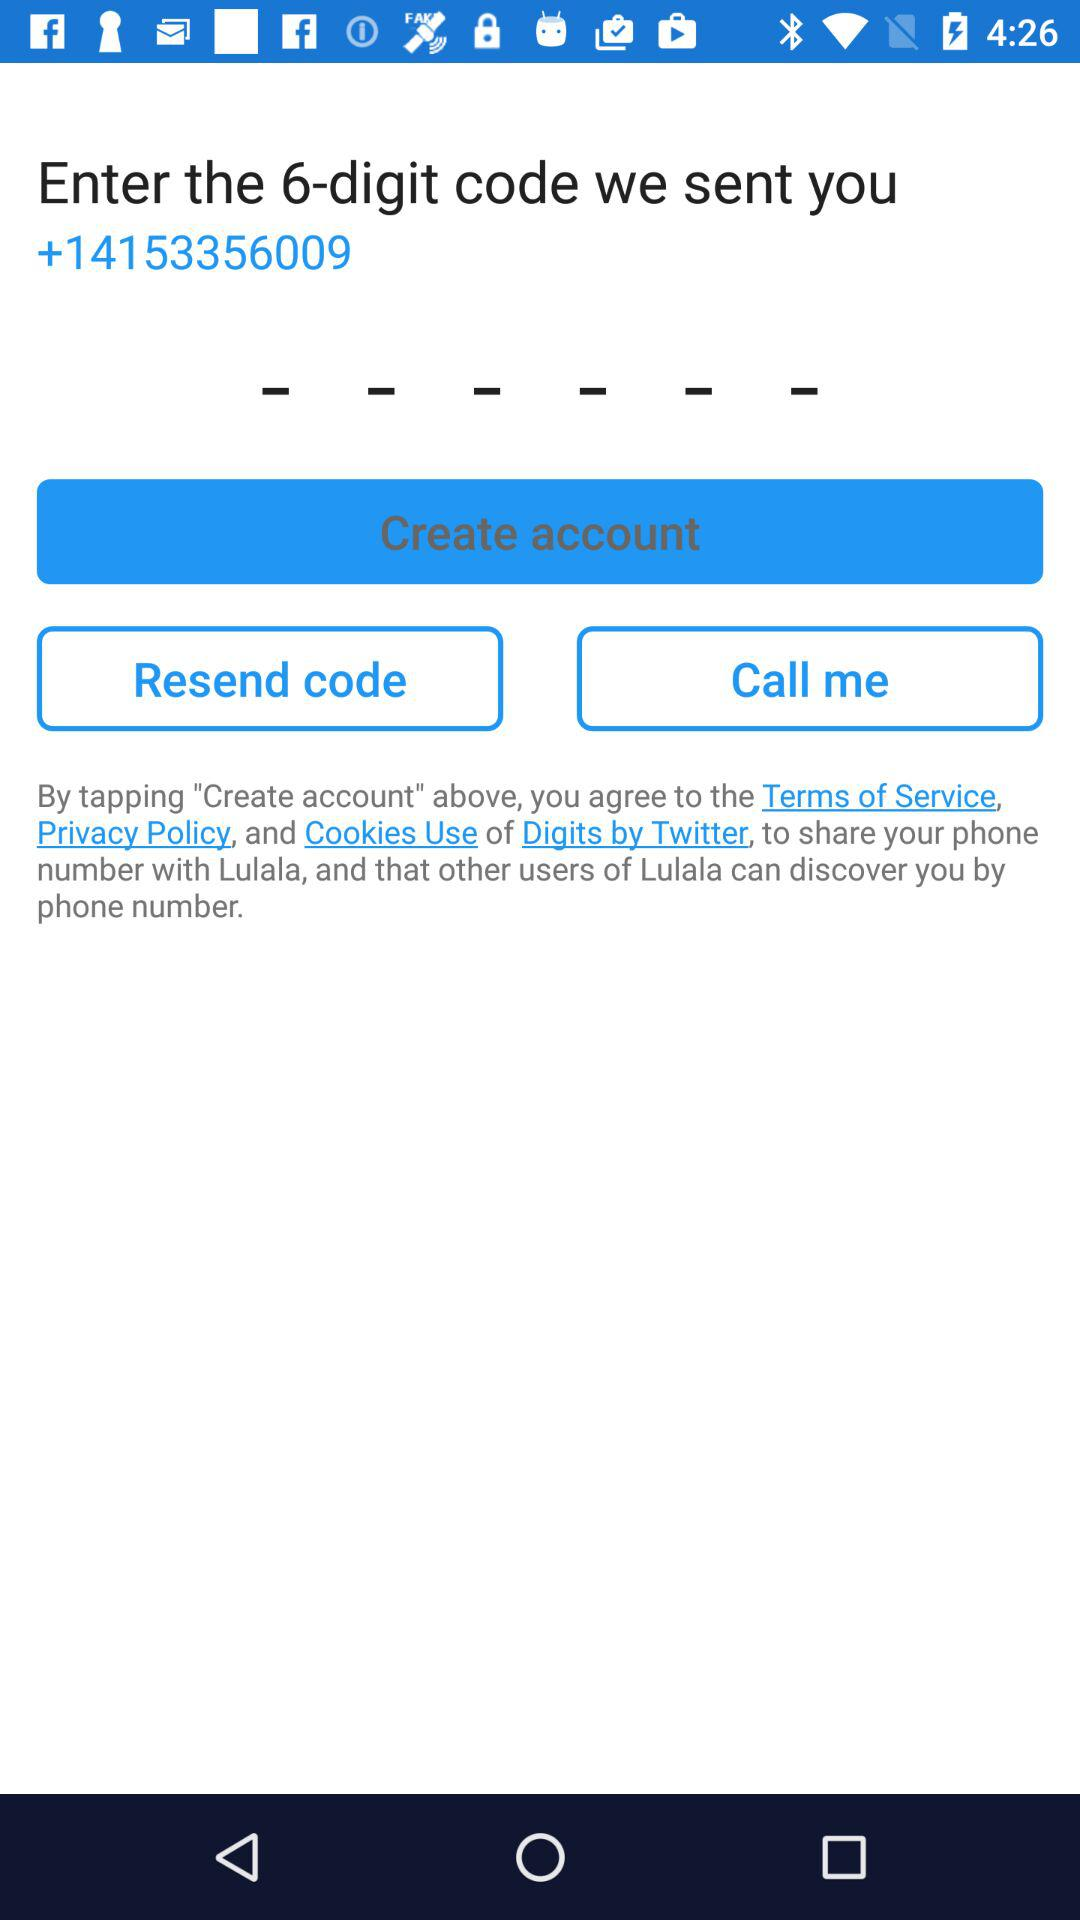What is the contact number? The contact number is "+14153356009". 